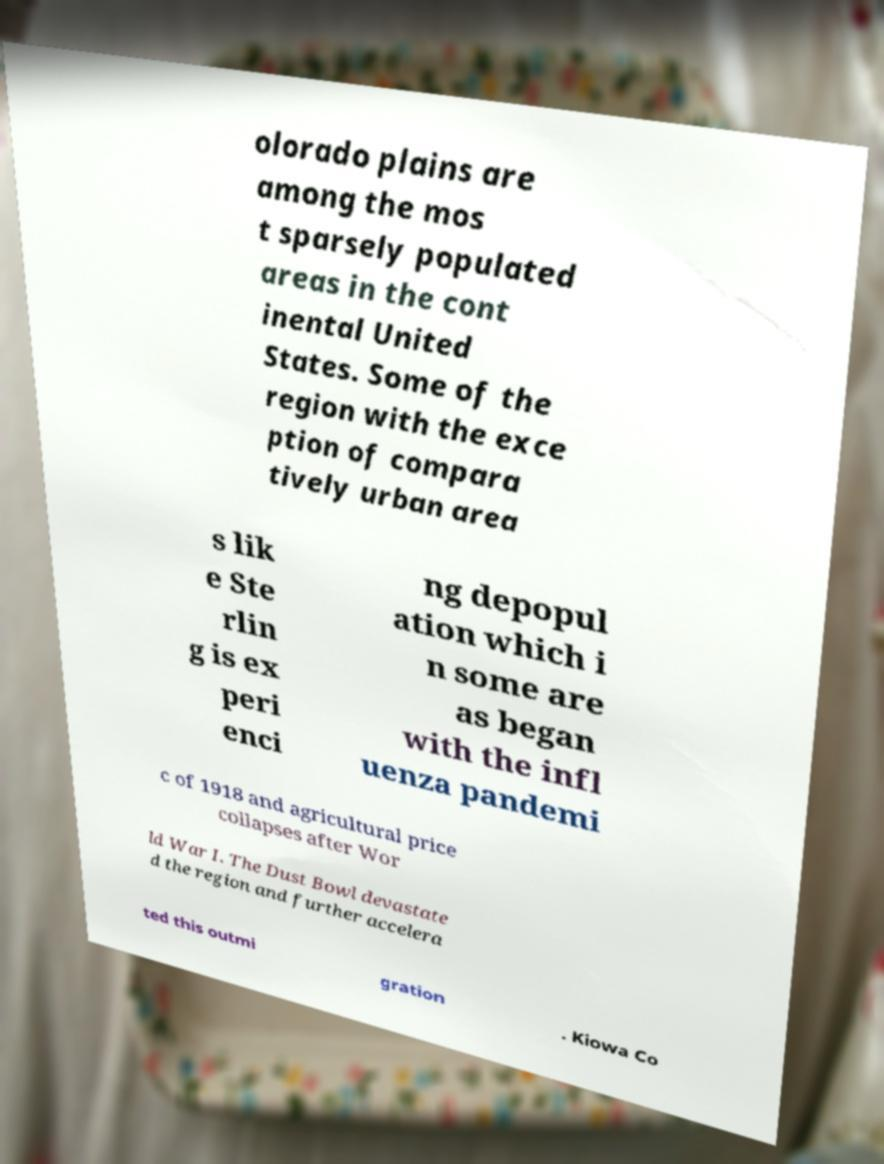Can you read and provide the text displayed in the image?This photo seems to have some interesting text. Can you extract and type it out for me? olorado plains are among the mos t sparsely populated areas in the cont inental United States. Some of the region with the exce ption of compara tively urban area s lik e Ste rlin g is ex peri enci ng depopul ation which i n some are as began with the infl uenza pandemi c of 1918 and agricultural price collapses after Wor ld War I. The Dust Bowl devastate d the region and further accelera ted this outmi gration . Kiowa Co 